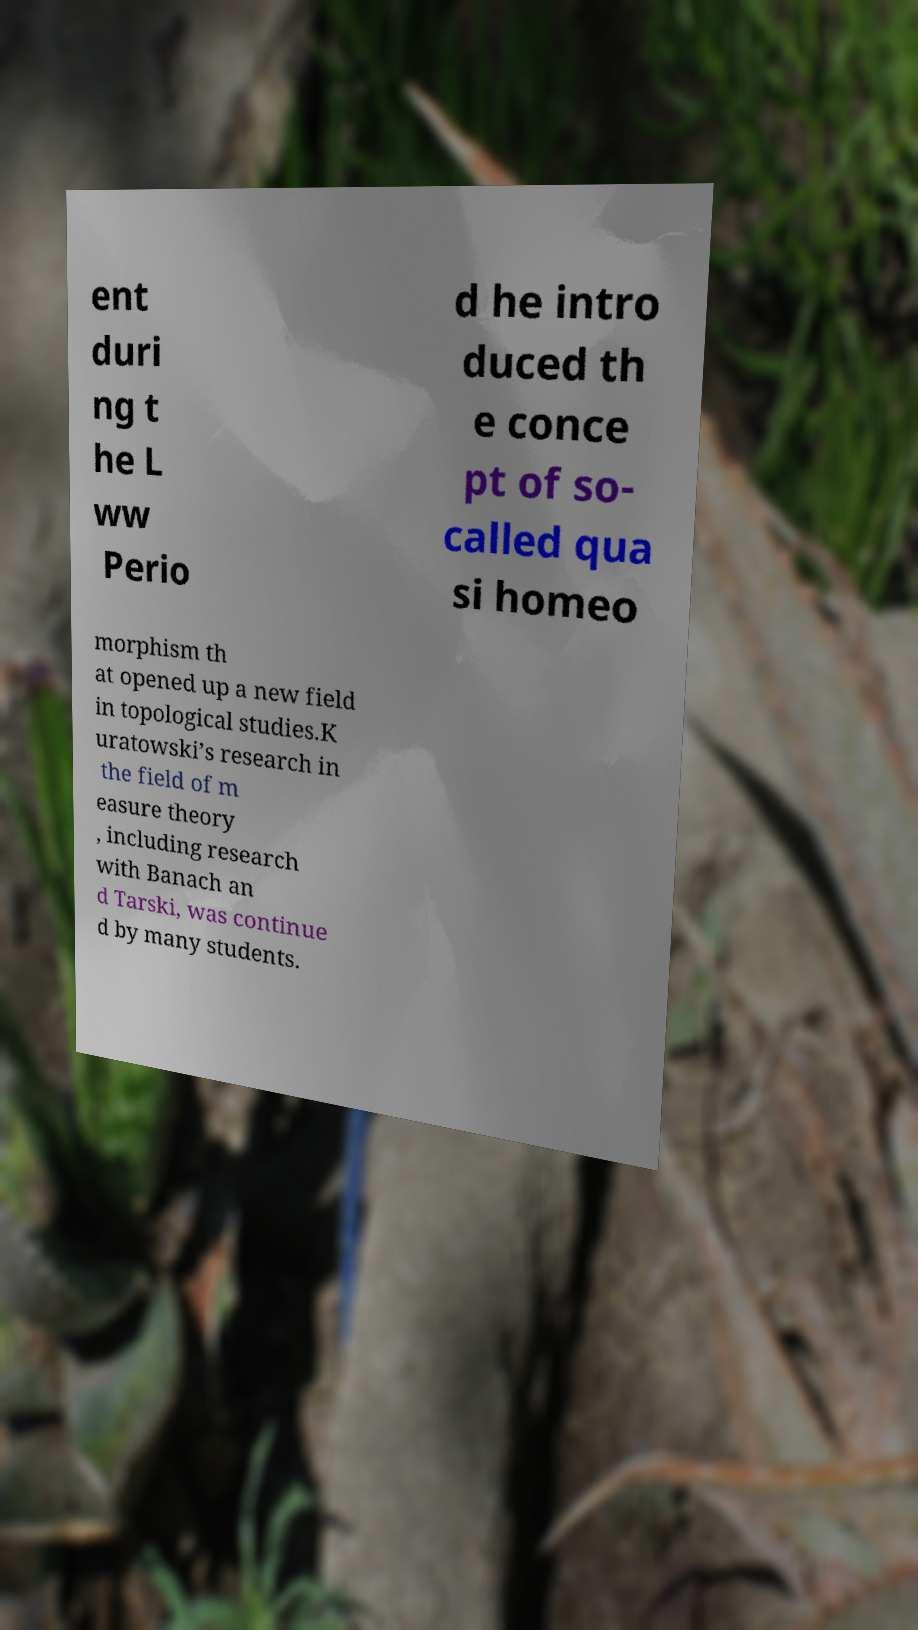Please read and relay the text visible in this image. What does it say? ent duri ng t he L ww Perio d he intro duced th e conce pt of so- called qua si homeo morphism th at opened up a new field in topological studies.K uratowski’s research in the field of m easure theory , including research with Banach an d Tarski, was continue d by many students. 